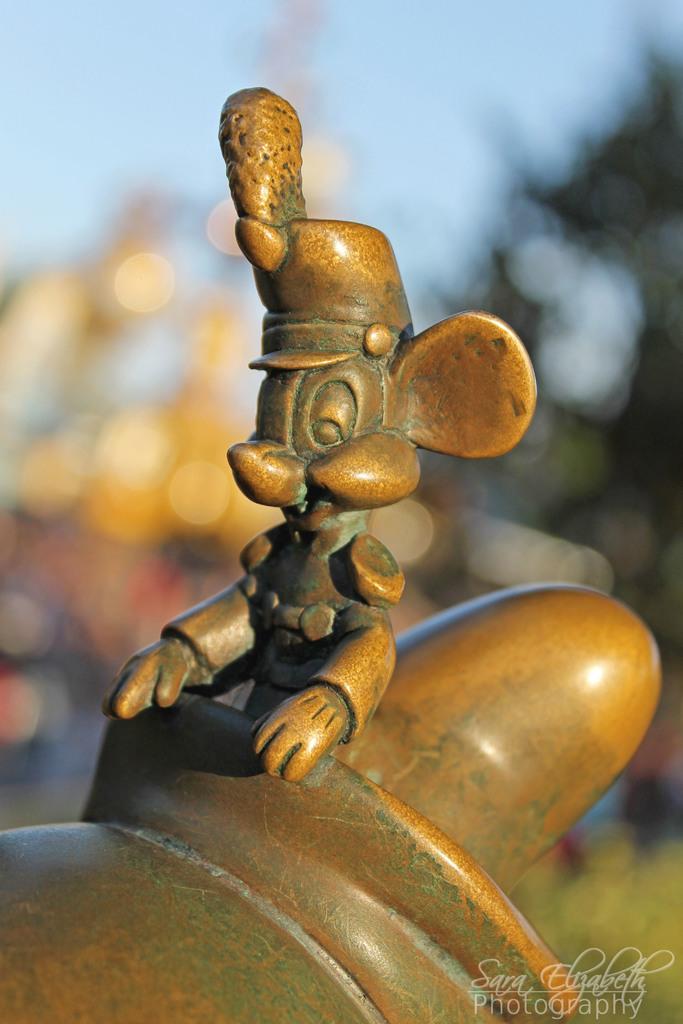Describe this image in one or two sentences. There is a wooden sculpture is present as we can see in the middle of this image. There is a watermark at the bottom right corner of this image. 